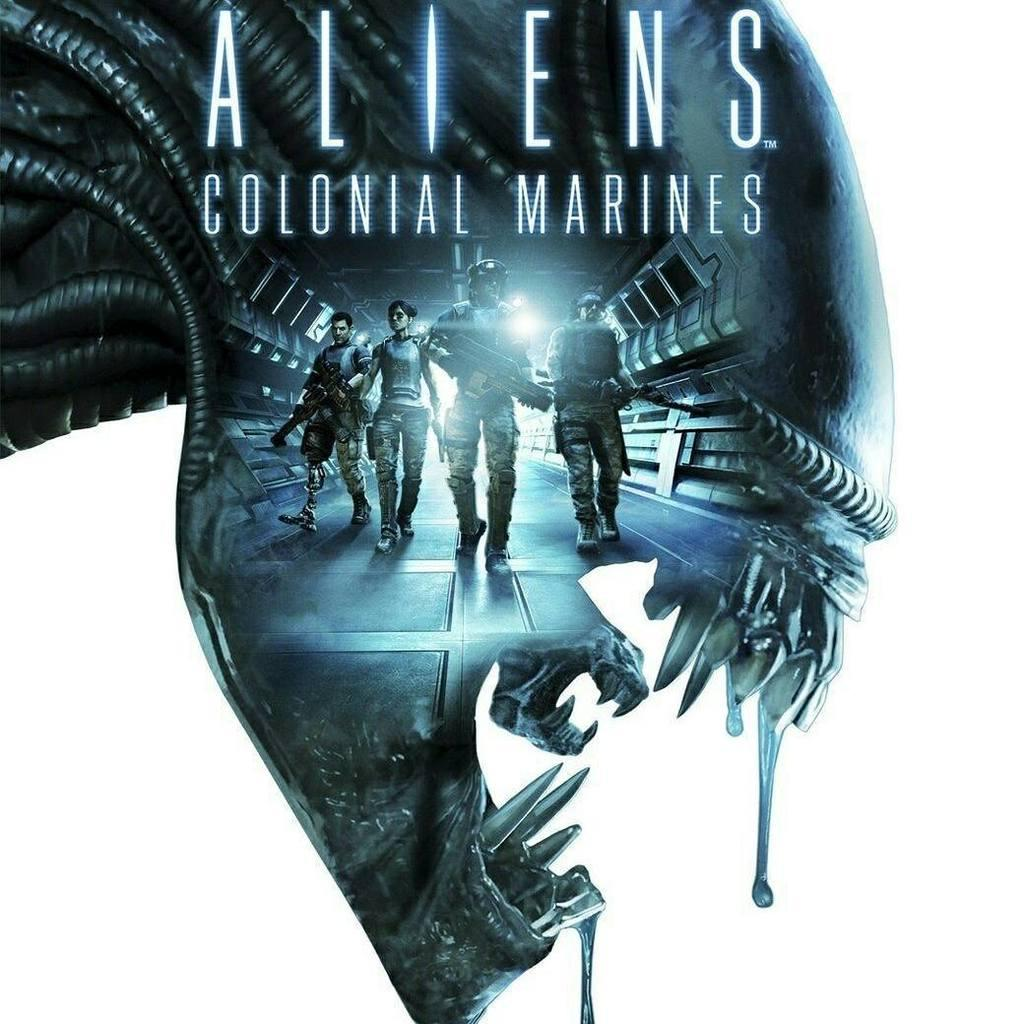<image>
Render a clear and concise summary of the photo. A movie poster that is advertising Aliens Colonial Marines. 